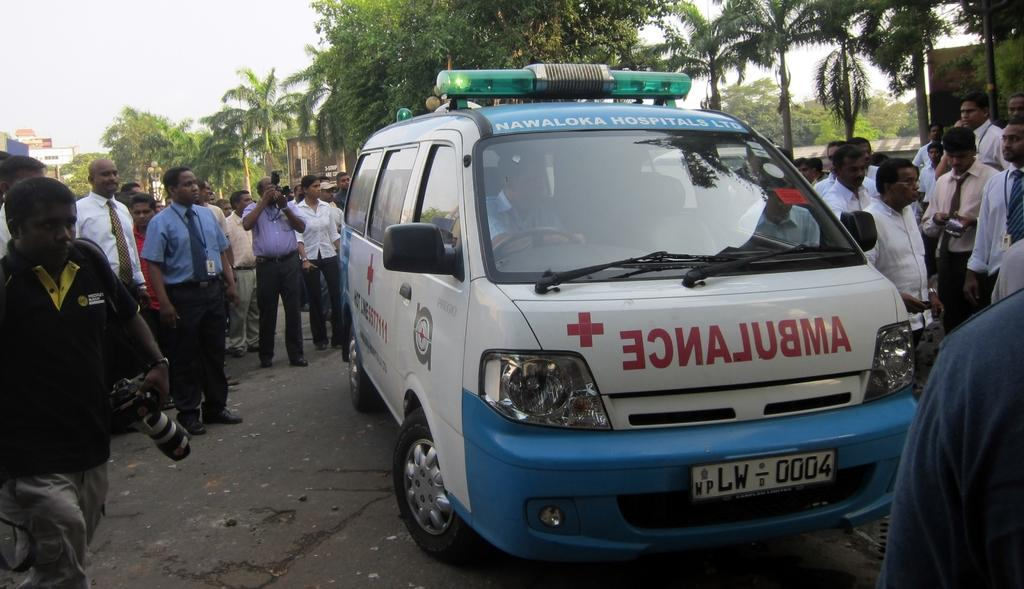What is the main subject of the image? The main subject of the image is a van. What are the people surrounding the van doing? The people are holding cameras. What can be seen in the background of the image? There are trees and buildings in the background of the image. What type of furniture can be seen inside the van in the image? There is no furniture visible inside the van in the image. What flavor of jelly is being served at the event in the image? There is no event or jelly present in the image; it features a van with people holding cameras. 